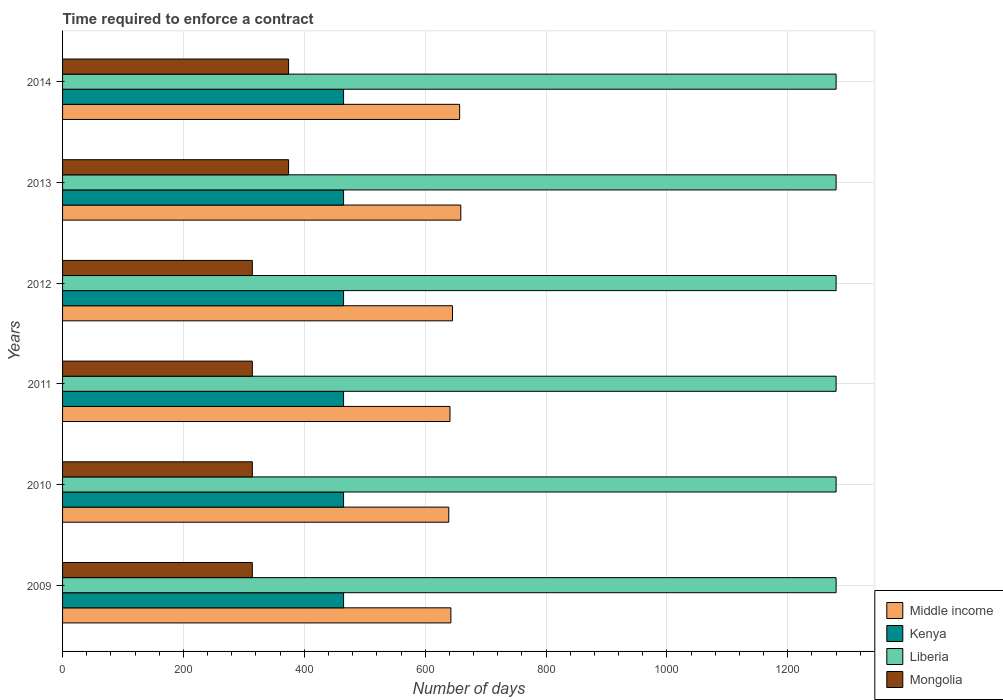Are the number of bars on each tick of the Y-axis equal?
Keep it short and to the point. Yes. How many bars are there on the 4th tick from the top?
Offer a very short reply. 4. How many bars are there on the 3rd tick from the bottom?
Your response must be concise. 4. In how many cases, is the number of bars for a given year not equal to the number of legend labels?
Ensure brevity in your answer.  0. What is the number of days required to enforce a contract in Kenya in 2010?
Give a very brief answer. 465. Across all years, what is the maximum number of days required to enforce a contract in Middle income?
Ensure brevity in your answer.  658.96. Across all years, what is the minimum number of days required to enforce a contract in Kenya?
Provide a succinct answer. 465. In which year was the number of days required to enforce a contract in Liberia minimum?
Offer a terse response. 2009. What is the total number of days required to enforce a contract in Mongolia in the graph?
Your answer should be compact. 2004. What is the difference between the number of days required to enforce a contract in Kenya in 2010 and that in 2011?
Your answer should be very brief. 0. What is the difference between the number of days required to enforce a contract in Liberia in 2013 and the number of days required to enforce a contract in Middle income in 2012?
Provide a succinct answer. 634.78. What is the average number of days required to enforce a contract in Middle income per year?
Offer a terse response. 647.31. In the year 2011, what is the difference between the number of days required to enforce a contract in Liberia and number of days required to enforce a contract in Kenya?
Offer a terse response. 815. In how many years, is the number of days required to enforce a contract in Middle income greater than 880 days?
Offer a terse response. 0. What is the ratio of the number of days required to enforce a contract in Middle income in 2009 to that in 2010?
Your answer should be compact. 1.01. Is the number of days required to enforce a contract in Liberia in 2009 less than that in 2013?
Make the answer very short. No. What is the difference between the highest and the second highest number of days required to enforce a contract in Mongolia?
Offer a terse response. 0. What does the 3rd bar from the top in 2009 represents?
Provide a succinct answer. Kenya. What does the 4th bar from the bottom in 2012 represents?
Provide a short and direct response. Mongolia. Is it the case that in every year, the sum of the number of days required to enforce a contract in Kenya and number of days required to enforce a contract in Middle income is greater than the number of days required to enforce a contract in Mongolia?
Ensure brevity in your answer.  Yes. Are all the bars in the graph horizontal?
Your answer should be compact. Yes. How many years are there in the graph?
Your answer should be compact. 6. Does the graph contain any zero values?
Provide a short and direct response. No. Where does the legend appear in the graph?
Your response must be concise. Bottom right. What is the title of the graph?
Your answer should be compact. Time required to enforce a contract. What is the label or title of the X-axis?
Provide a short and direct response. Number of days. What is the label or title of the Y-axis?
Offer a terse response. Years. What is the Number of days of Middle income in 2009?
Your answer should be compact. 642.56. What is the Number of days of Kenya in 2009?
Offer a very short reply. 465. What is the Number of days of Liberia in 2009?
Give a very brief answer. 1280. What is the Number of days in Mongolia in 2009?
Offer a very short reply. 314. What is the Number of days of Middle income in 2010?
Your answer should be compact. 639.04. What is the Number of days of Kenya in 2010?
Keep it short and to the point. 465. What is the Number of days of Liberia in 2010?
Offer a very short reply. 1280. What is the Number of days of Mongolia in 2010?
Your answer should be compact. 314. What is the Number of days of Middle income in 2011?
Your response must be concise. 641.06. What is the Number of days in Kenya in 2011?
Make the answer very short. 465. What is the Number of days of Liberia in 2011?
Your answer should be very brief. 1280. What is the Number of days of Mongolia in 2011?
Provide a short and direct response. 314. What is the Number of days in Middle income in 2012?
Give a very brief answer. 645.22. What is the Number of days of Kenya in 2012?
Your answer should be very brief. 465. What is the Number of days in Liberia in 2012?
Keep it short and to the point. 1280. What is the Number of days of Mongolia in 2012?
Your answer should be very brief. 314. What is the Number of days of Middle income in 2013?
Offer a very short reply. 658.96. What is the Number of days of Kenya in 2013?
Offer a terse response. 465. What is the Number of days of Liberia in 2013?
Your response must be concise. 1280. What is the Number of days of Mongolia in 2013?
Offer a very short reply. 374. What is the Number of days of Middle income in 2014?
Make the answer very short. 657.06. What is the Number of days in Kenya in 2014?
Offer a very short reply. 465. What is the Number of days in Liberia in 2014?
Give a very brief answer. 1280. What is the Number of days in Mongolia in 2014?
Make the answer very short. 374. Across all years, what is the maximum Number of days of Middle income?
Give a very brief answer. 658.96. Across all years, what is the maximum Number of days of Kenya?
Keep it short and to the point. 465. Across all years, what is the maximum Number of days in Liberia?
Keep it short and to the point. 1280. Across all years, what is the maximum Number of days in Mongolia?
Offer a very short reply. 374. Across all years, what is the minimum Number of days of Middle income?
Your answer should be compact. 639.04. Across all years, what is the minimum Number of days in Kenya?
Provide a short and direct response. 465. Across all years, what is the minimum Number of days in Liberia?
Provide a short and direct response. 1280. Across all years, what is the minimum Number of days in Mongolia?
Offer a very short reply. 314. What is the total Number of days in Middle income in the graph?
Provide a succinct answer. 3883.89. What is the total Number of days in Kenya in the graph?
Offer a very short reply. 2790. What is the total Number of days in Liberia in the graph?
Provide a succinct answer. 7680. What is the total Number of days of Mongolia in the graph?
Offer a very short reply. 2004. What is the difference between the Number of days in Middle income in 2009 and that in 2010?
Keep it short and to the point. 3.51. What is the difference between the Number of days in Kenya in 2009 and that in 2010?
Your answer should be compact. 0. What is the difference between the Number of days in Middle income in 2009 and that in 2011?
Make the answer very short. 1.5. What is the difference between the Number of days in Liberia in 2009 and that in 2011?
Provide a short and direct response. 0. What is the difference between the Number of days in Mongolia in 2009 and that in 2011?
Your answer should be compact. 0. What is the difference between the Number of days of Middle income in 2009 and that in 2012?
Ensure brevity in your answer.  -2.66. What is the difference between the Number of days in Kenya in 2009 and that in 2012?
Your answer should be very brief. 0. What is the difference between the Number of days in Liberia in 2009 and that in 2012?
Make the answer very short. 0. What is the difference between the Number of days in Middle income in 2009 and that in 2013?
Provide a short and direct response. -16.4. What is the difference between the Number of days of Kenya in 2009 and that in 2013?
Provide a short and direct response. 0. What is the difference between the Number of days in Mongolia in 2009 and that in 2013?
Offer a very short reply. -60. What is the difference between the Number of days of Middle income in 2009 and that in 2014?
Keep it short and to the point. -14.5. What is the difference between the Number of days of Liberia in 2009 and that in 2014?
Offer a terse response. 0. What is the difference between the Number of days in Mongolia in 2009 and that in 2014?
Provide a short and direct response. -60. What is the difference between the Number of days of Middle income in 2010 and that in 2011?
Offer a very short reply. -2.01. What is the difference between the Number of days of Kenya in 2010 and that in 2011?
Your answer should be very brief. 0. What is the difference between the Number of days of Middle income in 2010 and that in 2012?
Your response must be concise. -6.17. What is the difference between the Number of days of Kenya in 2010 and that in 2012?
Your response must be concise. 0. What is the difference between the Number of days of Mongolia in 2010 and that in 2012?
Provide a short and direct response. 0. What is the difference between the Number of days of Middle income in 2010 and that in 2013?
Ensure brevity in your answer.  -19.91. What is the difference between the Number of days in Kenya in 2010 and that in 2013?
Your response must be concise. 0. What is the difference between the Number of days in Mongolia in 2010 and that in 2013?
Offer a terse response. -60. What is the difference between the Number of days of Middle income in 2010 and that in 2014?
Provide a short and direct response. -18.01. What is the difference between the Number of days of Kenya in 2010 and that in 2014?
Make the answer very short. 0. What is the difference between the Number of days in Mongolia in 2010 and that in 2014?
Your answer should be very brief. -60. What is the difference between the Number of days in Middle income in 2011 and that in 2012?
Your response must be concise. -4.16. What is the difference between the Number of days of Kenya in 2011 and that in 2012?
Provide a succinct answer. 0. What is the difference between the Number of days of Mongolia in 2011 and that in 2012?
Keep it short and to the point. 0. What is the difference between the Number of days in Middle income in 2011 and that in 2013?
Offer a terse response. -17.9. What is the difference between the Number of days in Liberia in 2011 and that in 2013?
Provide a short and direct response. 0. What is the difference between the Number of days of Mongolia in 2011 and that in 2013?
Ensure brevity in your answer.  -60. What is the difference between the Number of days of Middle income in 2011 and that in 2014?
Your answer should be very brief. -16. What is the difference between the Number of days in Liberia in 2011 and that in 2014?
Your response must be concise. 0. What is the difference between the Number of days of Mongolia in 2011 and that in 2014?
Your answer should be very brief. -60. What is the difference between the Number of days of Middle income in 2012 and that in 2013?
Your answer should be compact. -13.74. What is the difference between the Number of days of Liberia in 2012 and that in 2013?
Give a very brief answer. 0. What is the difference between the Number of days of Mongolia in 2012 and that in 2013?
Give a very brief answer. -60. What is the difference between the Number of days of Middle income in 2012 and that in 2014?
Your answer should be very brief. -11.84. What is the difference between the Number of days of Kenya in 2012 and that in 2014?
Ensure brevity in your answer.  0. What is the difference between the Number of days in Liberia in 2012 and that in 2014?
Offer a very short reply. 0. What is the difference between the Number of days of Mongolia in 2012 and that in 2014?
Give a very brief answer. -60. What is the difference between the Number of days of Mongolia in 2013 and that in 2014?
Keep it short and to the point. 0. What is the difference between the Number of days in Middle income in 2009 and the Number of days in Kenya in 2010?
Provide a succinct answer. 177.56. What is the difference between the Number of days of Middle income in 2009 and the Number of days of Liberia in 2010?
Make the answer very short. -637.44. What is the difference between the Number of days in Middle income in 2009 and the Number of days in Mongolia in 2010?
Provide a short and direct response. 328.56. What is the difference between the Number of days in Kenya in 2009 and the Number of days in Liberia in 2010?
Ensure brevity in your answer.  -815. What is the difference between the Number of days of Kenya in 2009 and the Number of days of Mongolia in 2010?
Your answer should be very brief. 151. What is the difference between the Number of days of Liberia in 2009 and the Number of days of Mongolia in 2010?
Offer a very short reply. 966. What is the difference between the Number of days of Middle income in 2009 and the Number of days of Kenya in 2011?
Give a very brief answer. 177.56. What is the difference between the Number of days in Middle income in 2009 and the Number of days in Liberia in 2011?
Ensure brevity in your answer.  -637.44. What is the difference between the Number of days in Middle income in 2009 and the Number of days in Mongolia in 2011?
Offer a terse response. 328.56. What is the difference between the Number of days of Kenya in 2009 and the Number of days of Liberia in 2011?
Give a very brief answer. -815. What is the difference between the Number of days in Kenya in 2009 and the Number of days in Mongolia in 2011?
Offer a terse response. 151. What is the difference between the Number of days of Liberia in 2009 and the Number of days of Mongolia in 2011?
Make the answer very short. 966. What is the difference between the Number of days in Middle income in 2009 and the Number of days in Kenya in 2012?
Give a very brief answer. 177.56. What is the difference between the Number of days in Middle income in 2009 and the Number of days in Liberia in 2012?
Your response must be concise. -637.44. What is the difference between the Number of days of Middle income in 2009 and the Number of days of Mongolia in 2012?
Your response must be concise. 328.56. What is the difference between the Number of days in Kenya in 2009 and the Number of days in Liberia in 2012?
Provide a succinct answer. -815. What is the difference between the Number of days in Kenya in 2009 and the Number of days in Mongolia in 2012?
Your response must be concise. 151. What is the difference between the Number of days in Liberia in 2009 and the Number of days in Mongolia in 2012?
Keep it short and to the point. 966. What is the difference between the Number of days of Middle income in 2009 and the Number of days of Kenya in 2013?
Give a very brief answer. 177.56. What is the difference between the Number of days in Middle income in 2009 and the Number of days in Liberia in 2013?
Offer a terse response. -637.44. What is the difference between the Number of days in Middle income in 2009 and the Number of days in Mongolia in 2013?
Offer a terse response. 268.56. What is the difference between the Number of days of Kenya in 2009 and the Number of days of Liberia in 2013?
Make the answer very short. -815. What is the difference between the Number of days of Kenya in 2009 and the Number of days of Mongolia in 2013?
Provide a short and direct response. 91. What is the difference between the Number of days of Liberia in 2009 and the Number of days of Mongolia in 2013?
Provide a succinct answer. 906. What is the difference between the Number of days in Middle income in 2009 and the Number of days in Kenya in 2014?
Make the answer very short. 177.56. What is the difference between the Number of days of Middle income in 2009 and the Number of days of Liberia in 2014?
Give a very brief answer. -637.44. What is the difference between the Number of days of Middle income in 2009 and the Number of days of Mongolia in 2014?
Keep it short and to the point. 268.56. What is the difference between the Number of days in Kenya in 2009 and the Number of days in Liberia in 2014?
Make the answer very short. -815. What is the difference between the Number of days of Kenya in 2009 and the Number of days of Mongolia in 2014?
Provide a short and direct response. 91. What is the difference between the Number of days in Liberia in 2009 and the Number of days in Mongolia in 2014?
Ensure brevity in your answer.  906. What is the difference between the Number of days of Middle income in 2010 and the Number of days of Kenya in 2011?
Your answer should be compact. 174.04. What is the difference between the Number of days in Middle income in 2010 and the Number of days in Liberia in 2011?
Your answer should be compact. -640.96. What is the difference between the Number of days of Middle income in 2010 and the Number of days of Mongolia in 2011?
Your answer should be compact. 325.04. What is the difference between the Number of days of Kenya in 2010 and the Number of days of Liberia in 2011?
Your response must be concise. -815. What is the difference between the Number of days in Kenya in 2010 and the Number of days in Mongolia in 2011?
Ensure brevity in your answer.  151. What is the difference between the Number of days of Liberia in 2010 and the Number of days of Mongolia in 2011?
Offer a terse response. 966. What is the difference between the Number of days of Middle income in 2010 and the Number of days of Kenya in 2012?
Provide a succinct answer. 174.04. What is the difference between the Number of days in Middle income in 2010 and the Number of days in Liberia in 2012?
Your response must be concise. -640.96. What is the difference between the Number of days in Middle income in 2010 and the Number of days in Mongolia in 2012?
Your answer should be compact. 325.04. What is the difference between the Number of days in Kenya in 2010 and the Number of days in Liberia in 2012?
Offer a very short reply. -815. What is the difference between the Number of days of Kenya in 2010 and the Number of days of Mongolia in 2012?
Provide a succinct answer. 151. What is the difference between the Number of days in Liberia in 2010 and the Number of days in Mongolia in 2012?
Offer a very short reply. 966. What is the difference between the Number of days in Middle income in 2010 and the Number of days in Kenya in 2013?
Your response must be concise. 174.04. What is the difference between the Number of days in Middle income in 2010 and the Number of days in Liberia in 2013?
Provide a short and direct response. -640.96. What is the difference between the Number of days of Middle income in 2010 and the Number of days of Mongolia in 2013?
Make the answer very short. 265.04. What is the difference between the Number of days in Kenya in 2010 and the Number of days in Liberia in 2013?
Provide a succinct answer. -815. What is the difference between the Number of days in Kenya in 2010 and the Number of days in Mongolia in 2013?
Make the answer very short. 91. What is the difference between the Number of days of Liberia in 2010 and the Number of days of Mongolia in 2013?
Your answer should be compact. 906. What is the difference between the Number of days of Middle income in 2010 and the Number of days of Kenya in 2014?
Ensure brevity in your answer.  174.04. What is the difference between the Number of days in Middle income in 2010 and the Number of days in Liberia in 2014?
Offer a terse response. -640.96. What is the difference between the Number of days of Middle income in 2010 and the Number of days of Mongolia in 2014?
Offer a terse response. 265.04. What is the difference between the Number of days in Kenya in 2010 and the Number of days in Liberia in 2014?
Your answer should be compact. -815. What is the difference between the Number of days of Kenya in 2010 and the Number of days of Mongolia in 2014?
Your answer should be very brief. 91. What is the difference between the Number of days in Liberia in 2010 and the Number of days in Mongolia in 2014?
Offer a terse response. 906. What is the difference between the Number of days in Middle income in 2011 and the Number of days in Kenya in 2012?
Your answer should be very brief. 176.06. What is the difference between the Number of days in Middle income in 2011 and the Number of days in Liberia in 2012?
Provide a short and direct response. -638.94. What is the difference between the Number of days in Middle income in 2011 and the Number of days in Mongolia in 2012?
Give a very brief answer. 327.06. What is the difference between the Number of days of Kenya in 2011 and the Number of days of Liberia in 2012?
Give a very brief answer. -815. What is the difference between the Number of days of Kenya in 2011 and the Number of days of Mongolia in 2012?
Provide a short and direct response. 151. What is the difference between the Number of days in Liberia in 2011 and the Number of days in Mongolia in 2012?
Give a very brief answer. 966. What is the difference between the Number of days of Middle income in 2011 and the Number of days of Kenya in 2013?
Provide a succinct answer. 176.06. What is the difference between the Number of days in Middle income in 2011 and the Number of days in Liberia in 2013?
Provide a short and direct response. -638.94. What is the difference between the Number of days in Middle income in 2011 and the Number of days in Mongolia in 2013?
Provide a short and direct response. 267.06. What is the difference between the Number of days of Kenya in 2011 and the Number of days of Liberia in 2013?
Offer a terse response. -815. What is the difference between the Number of days in Kenya in 2011 and the Number of days in Mongolia in 2013?
Provide a succinct answer. 91. What is the difference between the Number of days in Liberia in 2011 and the Number of days in Mongolia in 2013?
Ensure brevity in your answer.  906. What is the difference between the Number of days of Middle income in 2011 and the Number of days of Kenya in 2014?
Your response must be concise. 176.06. What is the difference between the Number of days in Middle income in 2011 and the Number of days in Liberia in 2014?
Offer a very short reply. -638.94. What is the difference between the Number of days of Middle income in 2011 and the Number of days of Mongolia in 2014?
Your answer should be very brief. 267.06. What is the difference between the Number of days in Kenya in 2011 and the Number of days in Liberia in 2014?
Offer a very short reply. -815. What is the difference between the Number of days of Kenya in 2011 and the Number of days of Mongolia in 2014?
Your response must be concise. 91. What is the difference between the Number of days in Liberia in 2011 and the Number of days in Mongolia in 2014?
Offer a very short reply. 906. What is the difference between the Number of days in Middle income in 2012 and the Number of days in Kenya in 2013?
Your answer should be compact. 180.22. What is the difference between the Number of days of Middle income in 2012 and the Number of days of Liberia in 2013?
Offer a very short reply. -634.78. What is the difference between the Number of days of Middle income in 2012 and the Number of days of Mongolia in 2013?
Provide a succinct answer. 271.22. What is the difference between the Number of days in Kenya in 2012 and the Number of days in Liberia in 2013?
Ensure brevity in your answer.  -815. What is the difference between the Number of days of Kenya in 2012 and the Number of days of Mongolia in 2013?
Offer a very short reply. 91. What is the difference between the Number of days of Liberia in 2012 and the Number of days of Mongolia in 2013?
Provide a succinct answer. 906. What is the difference between the Number of days in Middle income in 2012 and the Number of days in Kenya in 2014?
Make the answer very short. 180.22. What is the difference between the Number of days of Middle income in 2012 and the Number of days of Liberia in 2014?
Ensure brevity in your answer.  -634.78. What is the difference between the Number of days of Middle income in 2012 and the Number of days of Mongolia in 2014?
Make the answer very short. 271.22. What is the difference between the Number of days in Kenya in 2012 and the Number of days in Liberia in 2014?
Provide a short and direct response. -815. What is the difference between the Number of days of Kenya in 2012 and the Number of days of Mongolia in 2014?
Provide a short and direct response. 91. What is the difference between the Number of days in Liberia in 2012 and the Number of days in Mongolia in 2014?
Ensure brevity in your answer.  906. What is the difference between the Number of days of Middle income in 2013 and the Number of days of Kenya in 2014?
Provide a succinct answer. 193.96. What is the difference between the Number of days of Middle income in 2013 and the Number of days of Liberia in 2014?
Give a very brief answer. -621.04. What is the difference between the Number of days of Middle income in 2013 and the Number of days of Mongolia in 2014?
Provide a succinct answer. 284.96. What is the difference between the Number of days of Kenya in 2013 and the Number of days of Liberia in 2014?
Provide a short and direct response. -815. What is the difference between the Number of days in Kenya in 2013 and the Number of days in Mongolia in 2014?
Your answer should be very brief. 91. What is the difference between the Number of days of Liberia in 2013 and the Number of days of Mongolia in 2014?
Offer a terse response. 906. What is the average Number of days in Middle income per year?
Provide a short and direct response. 647.31. What is the average Number of days of Kenya per year?
Make the answer very short. 465. What is the average Number of days in Liberia per year?
Your response must be concise. 1280. What is the average Number of days in Mongolia per year?
Keep it short and to the point. 334. In the year 2009, what is the difference between the Number of days in Middle income and Number of days in Kenya?
Your response must be concise. 177.56. In the year 2009, what is the difference between the Number of days in Middle income and Number of days in Liberia?
Your response must be concise. -637.44. In the year 2009, what is the difference between the Number of days in Middle income and Number of days in Mongolia?
Your response must be concise. 328.56. In the year 2009, what is the difference between the Number of days in Kenya and Number of days in Liberia?
Keep it short and to the point. -815. In the year 2009, what is the difference between the Number of days of Kenya and Number of days of Mongolia?
Give a very brief answer. 151. In the year 2009, what is the difference between the Number of days of Liberia and Number of days of Mongolia?
Make the answer very short. 966. In the year 2010, what is the difference between the Number of days in Middle income and Number of days in Kenya?
Make the answer very short. 174.04. In the year 2010, what is the difference between the Number of days of Middle income and Number of days of Liberia?
Your answer should be compact. -640.96. In the year 2010, what is the difference between the Number of days of Middle income and Number of days of Mongolia?
Make the answer very short. 325.04. In the year 2010, what is the difference between the Number of days of Kenya and Number of days of Liberia?
Keep it short and to the point. -815. In the year 2010, what is the difference between the Number of days in Kenya and Number of days in Mongolia?
Your answer should be compact. 151. In the year 2010, what is the difference between the Number of days in Liberia and Number of days in Mongolia?
Make the answer very short. 966. In the year 2011, what is the difference between the Number of days of Middle income and Number of days of Kenya?
Your response must be concise. 176.06. In the year 2011, what is the difference between the Number of days of Middle income and Number of days of Liberia?
Your answer should be compact. -638.94. In the year 2011, what is the difference between the Number of days of Middle income and Number of days of Mongolia?
Your answer should be very brief. 327.06. In the year 2011, what is the difference between the Number of days of Kenya and Number of days of Liberia?
Your answer should be compact. -815. In the year 2011, what is the difference between the Number of days in Kenya and Number of days in Mongolia?
Make the answer very short. 151. In the year 2011, what is the difference between the Number of days in Liberia and Number of days in Mongolia?
Your response must be concise. 966. In the year 2012, what is the difference between the Number of days of Middle income and Number of days of Kenya?
Offer a terse response. 180.22. In the year 2012, what is the difference between the Number of days in Middle income and Number of days in Liberia?
Your response must be concise. -634.78. In the year 2012, what is the difference between the Number of days of Middle income and Number of days of Mongolia?
Make the answer very short. 331.22. In the year 2012, what is the difference between the Number of days in Kenya and Number of days in Liberia?
Your response must be concise. -815. In the year 2012, what is the difference between the Number of days in Kenya and Number of days in Mongolia?
Your answer should be compact. 151. In the year 2012, what is the difference between the Number of days of Liberia and Number of days of Mongolia?
Offer a terse response. 966. In the year 2013, what is the difference between the Number of days in Middle income and Number of days in Kenya?
Your answer should be very brief. 193.96. In the year 2013, what is the difference between the Number of days of Middle income and Number of days of Liberia?
Provide a short and direct response. -621.04. In the year 2013, what is the difference between the Number of days in Middle income and Number of days in Mongolia?
Give a very brief answer. 284.96. In the year 2013, what is the difference between the Number of days in Kenya and Number of days in Liberia?
Offer a very short reply. -815. In the year 2013, what is the difference between the Number of days of Kenya and Number of days of Mongolia?
Provide a succinct answer. 91. In the year 2013, what is the difference between the Number of days of Liberia and Number of days of Mongolia?
Provide a short and direct response. 906. In the year 2014, what is the difference between the Number of days in Middle income and Number of days in Kenya?
Provide a short and direct response. 192.06. In the year 2014, what is the difference between the Number of days in Middle income and Number of days in Liberia?
Your answer should be compact. -622.94. In the year 2014, what is the difference between the Number of days of Middle income and Number of days of Mongolia?
Your answer should be very brief. 283.06. In the year 2014, what is the difference between the Number of days in Kenya and Number of days in Liberia?
Offer a very short reply. -815. In the year 2014, what is the difference between the Number of days in Kenya and Number of days in Mongolia?
Your response must be concise. 91. In the year 2014, what is the difference between the Number of days of Liberia and Number of days of Mongolia?
Your answer should be compact. 906. What is the ratio of the Number of days of Middle income in 2009 to that in 2010?
Your answer should be compact. 1.01. What is the ratio of the Number of days of Kenya in 2009 to that in 2010?
Your response must be concise. 1. What is the ratio of the Number of days in Liberia in 2009 to that in 2010?
Your response must be concise. 1. What is the ratio of the Number of days of Middle income in 2009 to that in 2011?
Make the answer very short. 1. What is the ratio of the Number of days of Kenya in 2009 to that in 2011?
Your answer should be very brief. 1. What is the ratio of the Number of days of Mongolia in 2009 to that in 2011?
Provide a succinct answer. 1. What is the ratio of the Number of days of Middle income in 2009 to that in 2012?
Keep it short and to the point. 1. What is the ratio of the Number of days in Kenya in 2009 to that in 2012?
Provide a succinct answer. 1. What is the ratio of the Number of days in Liberia in 2009 to that in 2012?
Make the answer very short. 1. What is the ratio of the Number of days in Middle income in 2009 to that in 2013?
Ensure brevity in your answer.  0.98. What is the ratio of the Number of days of Kenya in 2009 to that in 2013?
Keep it short and to the point. 1. What is the ratio of the Number of days in Mongolia in 2009 to that in 2013?
Your answer should be very brief. 0.84. What is the ratio of the Number of days of Middle income in 2009 to that in 2014?
Your response must be concise. 0.98. What is the ratio of the Number of days in Liberia in 2009 to that in 2014?
Your answer should be very brief. 1. What is the ratio of the Number of days of Mongolia in 2009 to that in 2014?
Provide a short and direct response. 0.84. What is the ratio of the Number of days of Kenya in 2010 to that in 2011?
Your answer should be compact. 1. What is the ratio of the Number of days in Mongolia in 2010 to that in 2011?
Offer a terse response. 1. What is the ratio of the Number of days of Kenya in 2010 to that in 2012?
Give a very brief answer. 1. What is the ratio of the Number of days of Middle income in 2010 to that in 2013?
Your answer should be compact. 0.97. What is the ratio of the Number of days in Liberia in 2010 to that in 2013?
Make the answer very short. 1. What is the ratio of the Number of days of Mongolia in 2010 to that in 2013?
Offer a terse response. 0.84. What is the ratio of the Number of days in Middle income in 2010 to that in 2014?
Give a very brief answer. 0.97. What is the ratio of the Number of days of Mongolia in 2010 to that in 2014?
Offer a terse response. 0.84. What is the ratio of the Number of days in Mongolia in 2011 to that in 2012?
Ensure brevity in your answer.  1. What is the ratio of the Number of days of Middle income in 2011 to that in 2013?
Make the answer very short. 0.97. What is the ratio of the Number of days of Mongolia in 2011 to that in 2013?
Make the answer very short. 0.84. What is the ratio of the Number of days of Middle income in 2011 to that in 2014?
Make the answer very short. 0.98. What is the ratio of the Number of days in Mongolia in 2011 to that in 2014?
Offer a terse response. 0.84. What is the ratio of the Number of days of Middle income in 2012 to that in 2013?
Make the answer very short. 0.98. What is the ratio of the Number of days of Kenya in 2012 to that in 2013?
Your answer should be compact. 1. What is the ratio of the Number of days in Liberia in 2012 to that in 2013?
Provide a short and direct response. 1. What is the ratio of the Number of days in Mongolia in 2012 to that in 2013?
Provide a succinct answer. 0.84. What is the ratio of the Number of days in Middle income in 2012 to that in 2014?
Provide a short and direct response. 0.98. What is the ratio of the Number of days in Kenya in 2012 to that in 2014?
Ensure brevity in your answer.  1. What is the ratio of the Number of days of Mongolia in 2012 to that in 2014?
Give a very brief answer. 0.84. What is the ratio of the Number of days in Middle income in 2013 to that in 2014?
Make the answer very short. 1. What is the ratio of the Number of days in Kenya in 2013 to that in 2014?
Offer a terse response. 1. What is the ratio of the Number of days of Mongolia in 2013 to that in 2014?
Make the answer very short. 1. What is the difference between the highest and the lowest Number of days of Middle income?
Ensure brevity in your answer.  19.91. What is the difference between the highest and the lowest Number of days of Liberia?
Ensure brevity in your answer.  0. What is the difference between the highest and the lowest Number of days of Mongolia?
Your response must be concise. 60. 